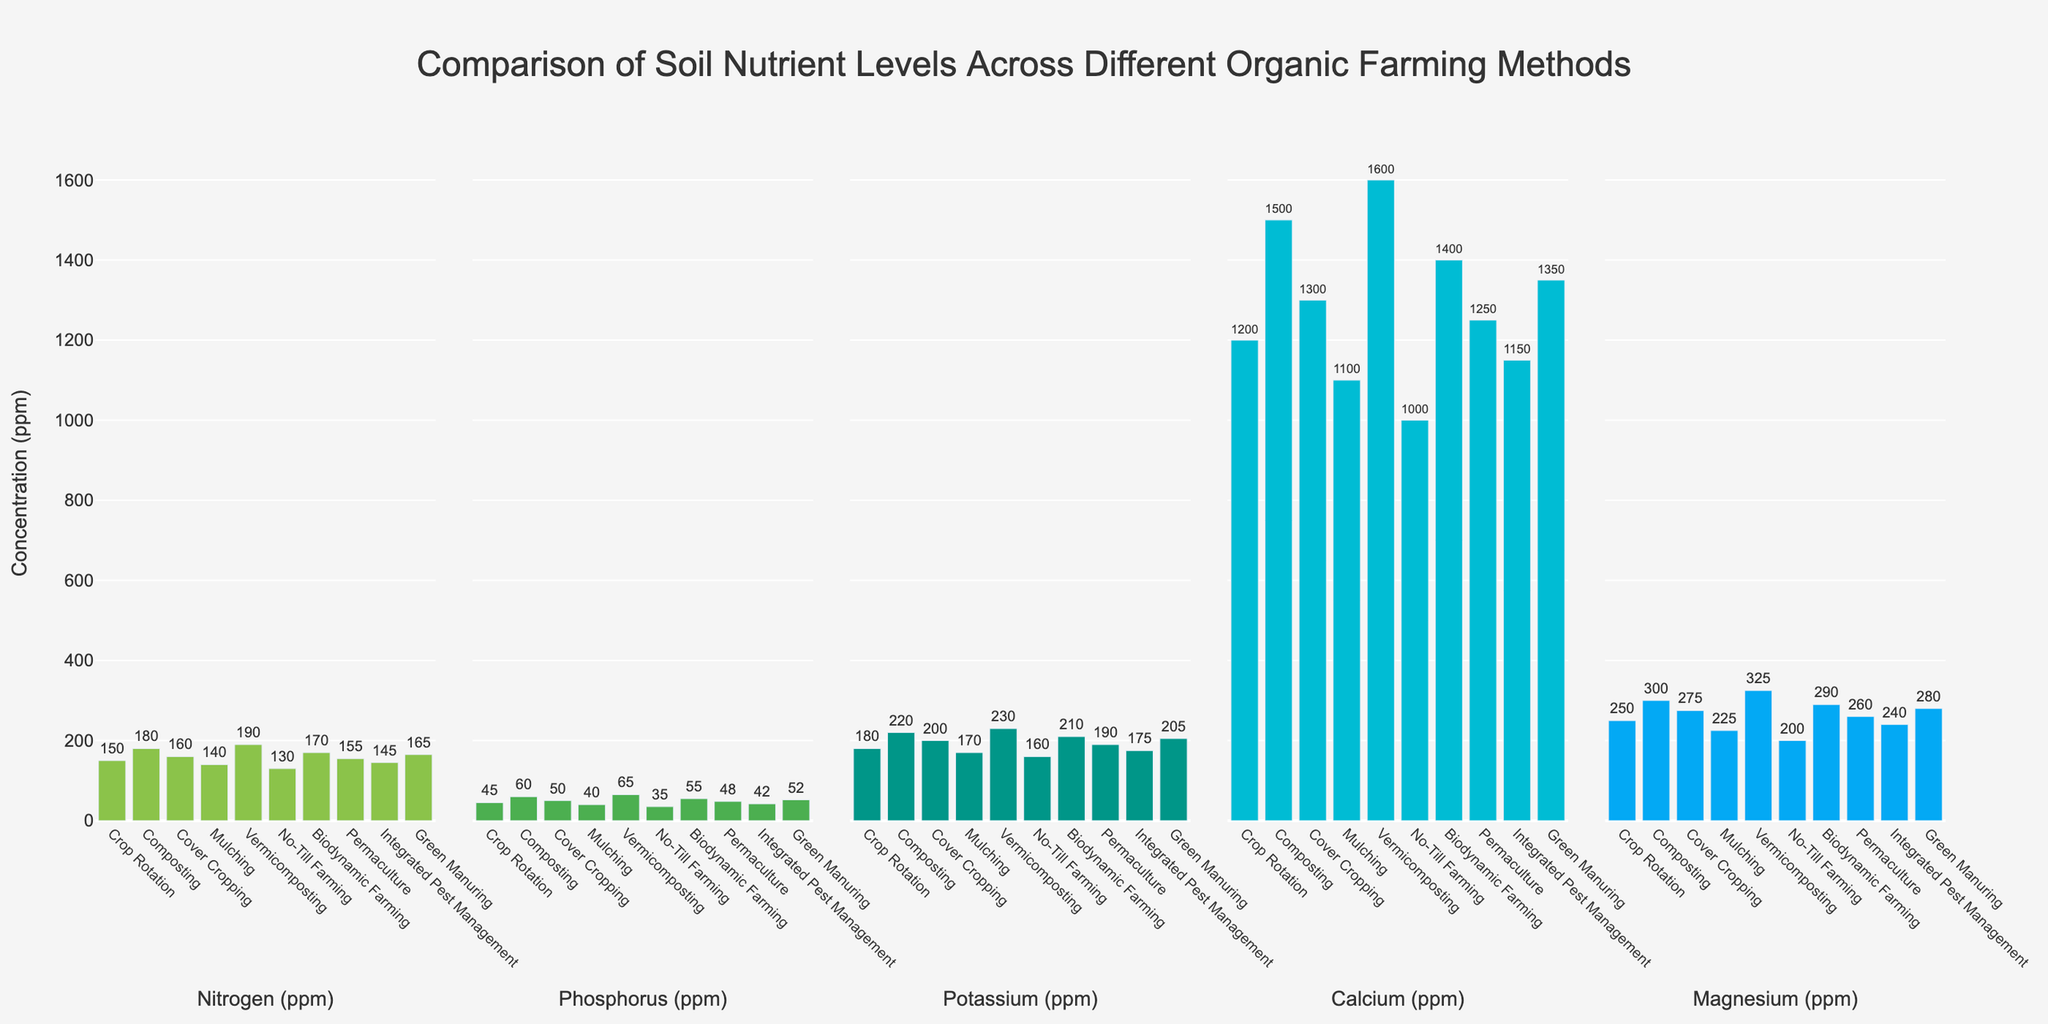What is the farming method with the highest Nitrogen level? Look at the Nitrogen (ppm) subplot and identify the bar with the greatest height. Vermicomposting has the tallest bar here.
Answer: Vermicomposting Which farming method has the lowest Phosphorus level? Look at the Phosphorus (ppm) subplot and identify the bar with the shortest height. No-Till Farming has the shortest bar.
Answer: No-Till Farming Compare the levels of Calcium in Crop Rotation and Green Manuring; which is higher? Look at the Calcium (ppm) subplot and compare the heights of the bars for Crop Rotation and Green Manuring. Green Manuring has a higher bar than Crop Rotation.
Answer: Green Manuring What is the average Magnesium (ppm) level across all farming methods? Add the Magnesium values for all methods and divide by the number of methods. (250+300+275+225+325+200+290+260+240+280) / 10 = 264.5
Answer: 264.5 Which nutrient shows the highest variation in levels across different farming methods? Compare the range of values across the nutrient subplots. Nitrogen shows the highest variation from 130 (No-Till Farming) to 190 (Vermicomposting).
Answer: Nitrogen Which farming method has near-equal levels of Nitrogen and Magnesium? Compare the Nitrogen and Magnesium bars within each method to find bars of similar height. Biodynamic Farming has near-equal levels (170 Nitrogen and 290 Magnesium).
Answer: Biodynamic Farming What is the difference in Potassium levels between Mulching and Biodynamic Farming methods? Subtract the Potassium value for Mulching from that of Biodynamic Farming: 210 - 170 = 40.
Answer: 40 Identify the method where Calcium and Magnesium levels are both above their median values. Find the median values: Calcium (1250), Magnesium (262.5). Check which methods have both nutrient levels above these values. Vermicomposting (1600 Calcium, 325 Magnesium), Composting (1500 Calcium, 300 Magnesium), Biodynamic Farming (1400 Calcium, 290 Magnesium), Green Manuring (1350 Calcium, 280 Magnesium), and Cover Cropping (1300 Calcium, 275 Magnesium) fulfill this criteria.
Answer: Vermicomposting, Composting, Biodynamic Farming, Green Manuring, Cover Cropping What is the combined total of Nitrogen and Phosphorus levels in Vermicomposting? Add the Nitrogen and Phosphorus values for Vermicomposting: 190 + 65 = 255.
Answer: 255 